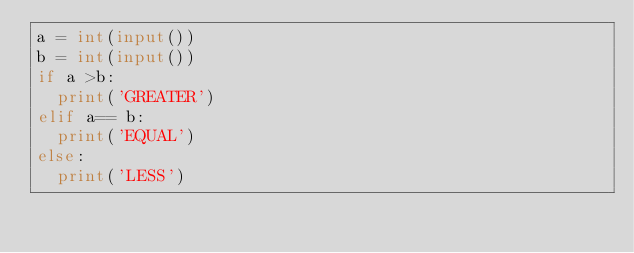<code> <loc_0><loc_0><loc_500><loc_500><_Python_>a = int(input())
b = int(input())
if a >b:
  print('GREATER')
elif a== b:
  print('EQUAL')
else:
  print('LESS')</code> 